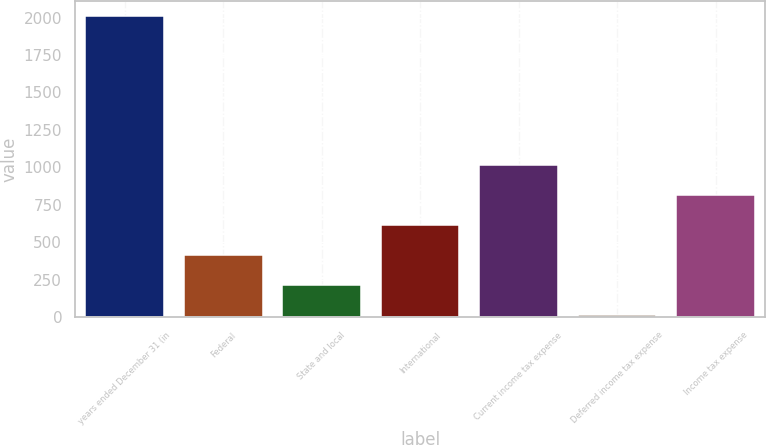Convert chart to OTSL. <chart><loc_0><loc_0><loc_500><loc_500><bar_chart><fcel>years ended December 31 (in<fcel>Federal<fcel>State and local<fcel>International<fcel>Current income tax expense<fcel>Deferred income tax expense<fcel>Income tax expense<nl><fcel>2012<fcel>416<fcel>216.5<fcel>615.5<fcel>1014.5<fcel>17<fcel>815<nl></chart> 